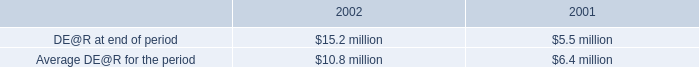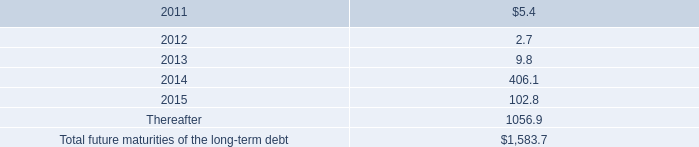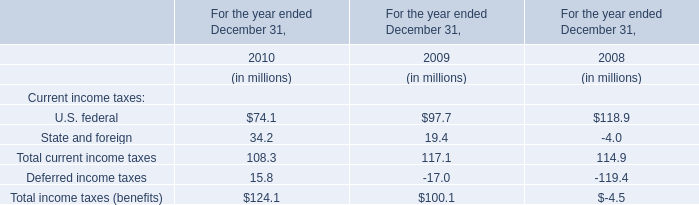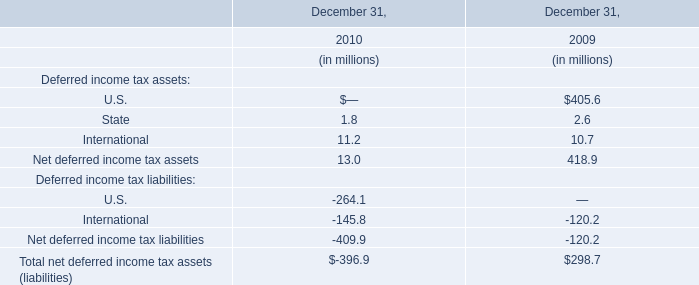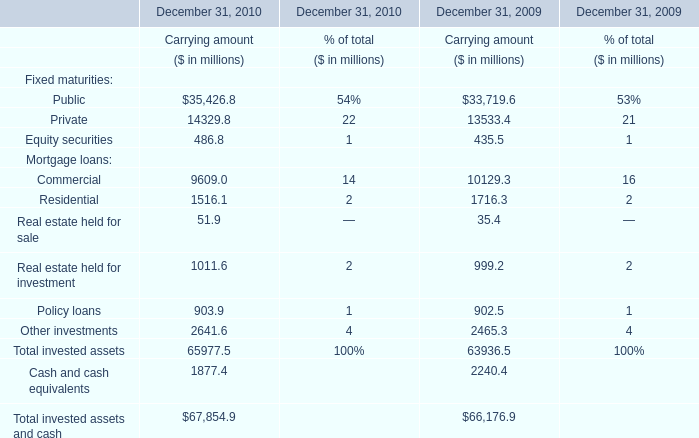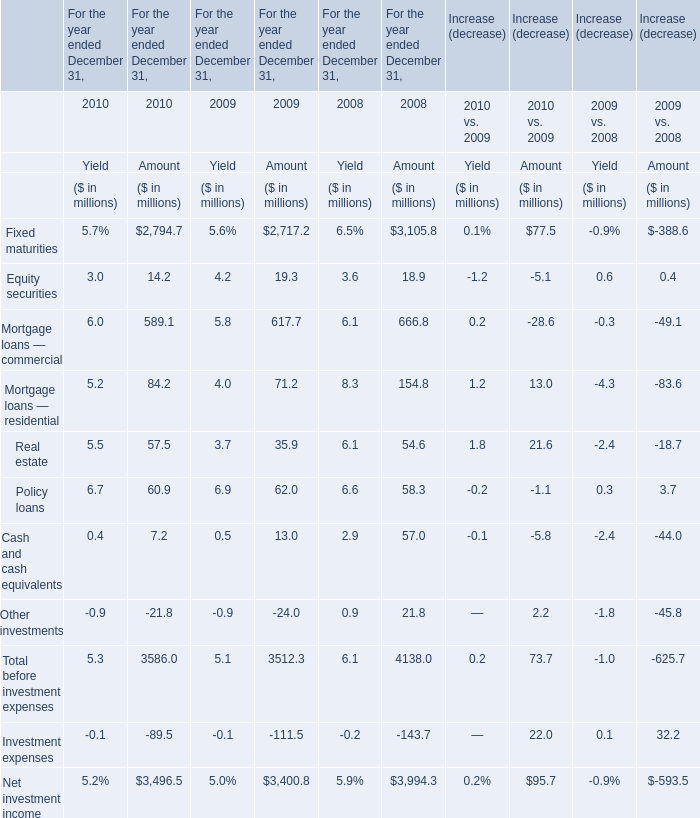What's the growth rate of Real estate held for sale in 2010? (in %) 
Computations: ((51.9 - 35.4) / 35.4)
Answer: 0.4661. 